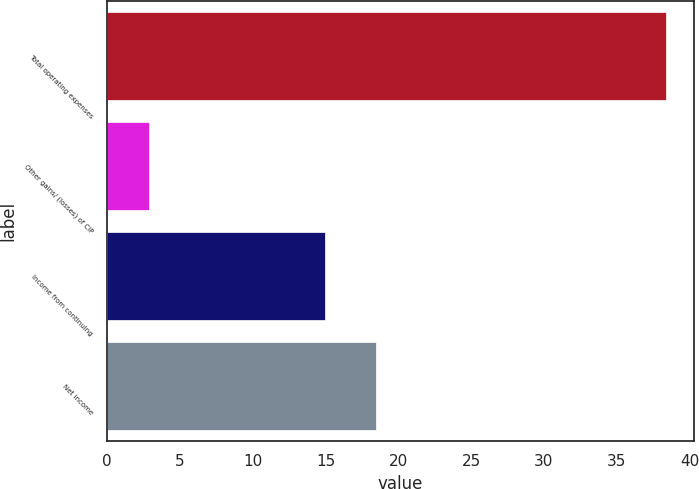Convert chart. <chart><loc_0><loc_0><loc_500><loc_500><bar_chart><fcel>Total operating expenses<fcel>Other gains/ (losses) of CIP<fcel>Income from continuing<fcel>Net income<nl><fcel>38.4<fcel>2.9<fcel>14.95<fcel>18.5<nl></chart> 